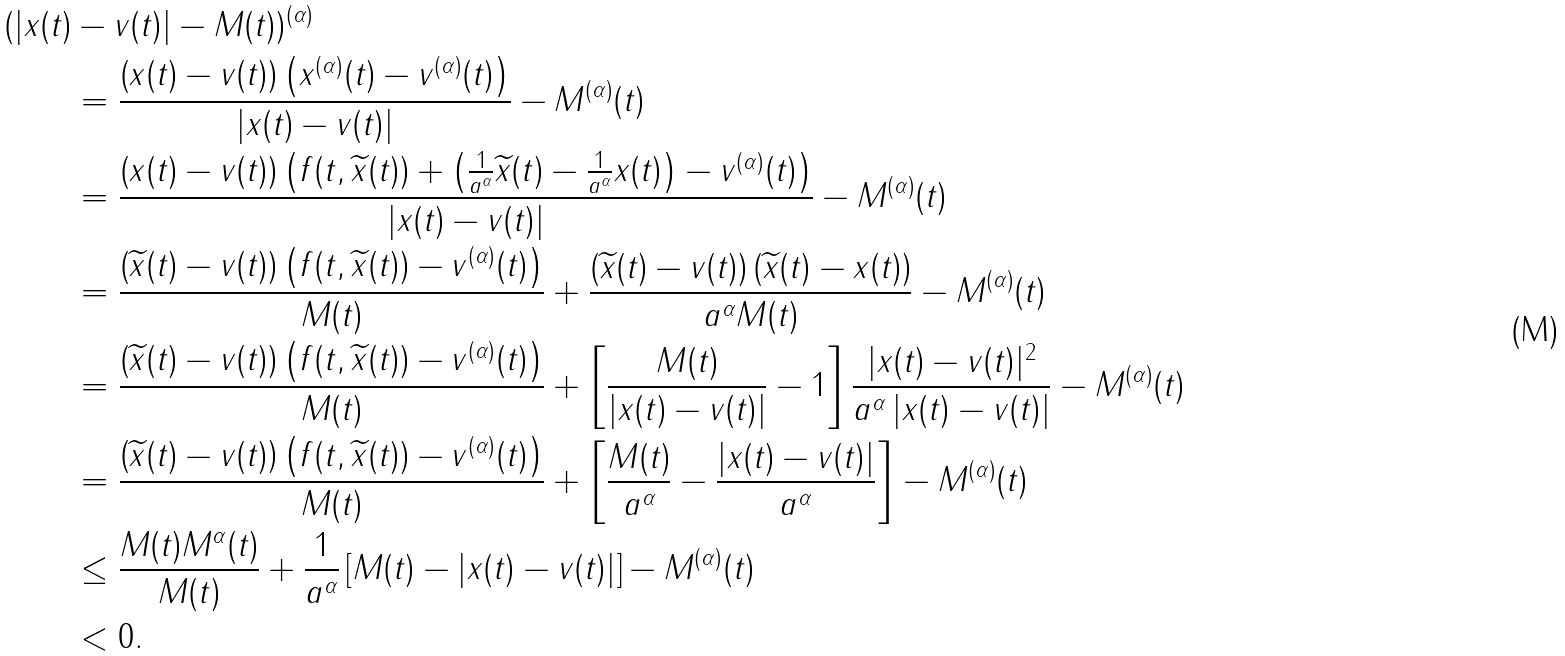<formula> <loc_0><loc_0><loc_500><loc_500>( | x ( t ) & - v ( t ) | - M ( t ) ) ^ { ( \alpha ) } \\ & = \frac { \left ( x ( t ) - v ( t ) \right ) \left ( x ^ { ( \alpha ) } ( t ) - v ^ { ( \alpha ) } ( t ) \right ) } { | x ( t ) - v ( t ) | } - M ^ { ( \alpha ) } ( t ) \\ & = \frac { \left ( x ( t ) - v ( t ) \right ) \left ( f ( t , \widetilde { x } ( t ) ) + \left ( \frac { 1 } { a ^ { \alpha } } \widetilde { x } ( t ) - \frac { 1 } { a ^ { \alpha } } x ( t ) \right ) - v ^ { ( \alpha ) } ( t ) \right ) } { | x ( t ) - v ( t ) | } - M ^ { ( \alpha ) } ( t ) \\ & = \frac { \left ( \widetilde { x } ( t ) - v ( t ) \right ) \left ( f ( t , \widetilde { x } ( t ) ) - v ^ { ( \alpha ) } ( t ) \right ) } { M ( t ) } + \frac { \left ( \widetilde { x } ( t ) - v ( t ) \right ) \left ( \widetilde { x } ( t ) - x ( t ) \right ) } { a ^ { \alpha } M ( t ) } - M ^ { ( \alpha ) } ( t ) \\ & = \frac { \left ( \widetilde { x } ( t ) - v ( t ) \right ) \left ( f ( t , \widetilde { x } ( t ) ) - v ^ { ( \alpha ) } ( t ) \right ) } { M ( t ) } + \left [ \frac { M ( t ) } { | x ( t ) - v ( t ) | } - 1 \right ] \frac { | x ( t ) - v ( t ) | ^ { 2 } } { a ^ { \alpha } \left | x ( t ) - v ( t ) \right | } - M ^ { ( \alpha ) } ( t ) \\ & = \frac { \left ( \widetilde { x } ( t ) - v ( t ) \right ) \left ( f ( t , \widetilde { x } ( t ) ) - v ^ { ( \alpha ) } ( t ) \right ) } { M ( t ) } + \left [ \frac { M ( t ) } { a ^ { \alpha } } - \frac { | x ( t ) - v ( t ) | } { a ^ { \alpha } } \right ] - M ^ { ( \alpha ) } ( t ) \\ & \leq \frac { M ( t ) M ^ { \alpha } ( t ) } { M ( t ) } + \frac { 1 } { a ^ { \alpha } } \left [ M ( t ) - | x ( t ) - v ( t ) | \right ] - M ^ { ( \alpha ) } ( t ) \\ & < 0 .</formula> 